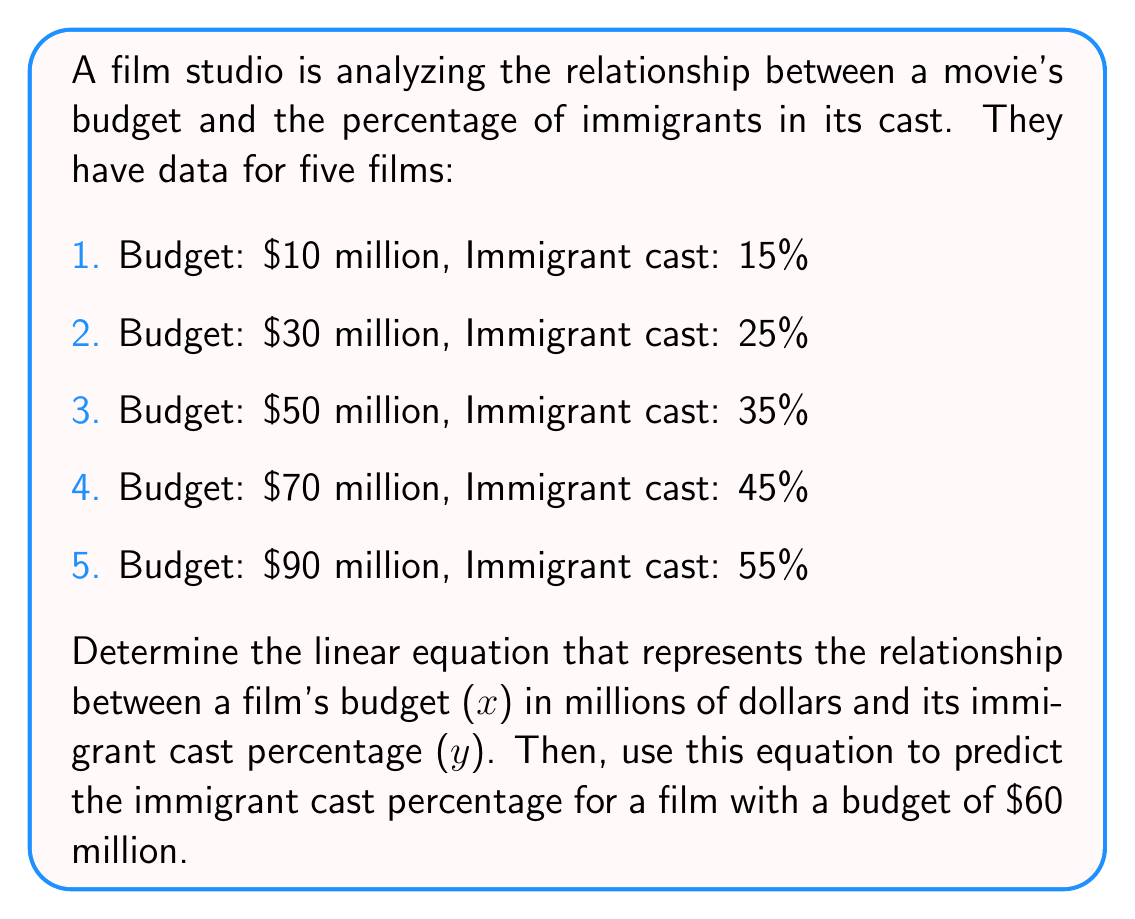Could you help me with this problem? To find the linear equation, we'll use the slope-intercept form: $y = mx + b$

Step 1: Calculate the slope (m)
Using the first and last data points:
$m = \frac{y_2 - y_1}{x_2 - x_1} = \frac{55 - 15}{90 - 10} = \frac{40}{80} = 0.5$

Step 2: Use the point-slope form to find b
Using the first data point (10, 15):
$y - y_1 = m(x - x_1)$
$15 = 0.5(10) + b$
$15 = 5 + b$
$b = 10$

Step 3: Write the linear equation
$y = 0.5x + 10$

Step 4: Predict the immigrant cast percentage for a $60 million budget
$y = 0.5(60) + 10 = 30 + 10 = 40$

Therefore, for a film with a $60 million budget, the predicted immigrant cast percentage is 40%.
Answer: $y = 0.5x + 10$; 40% 